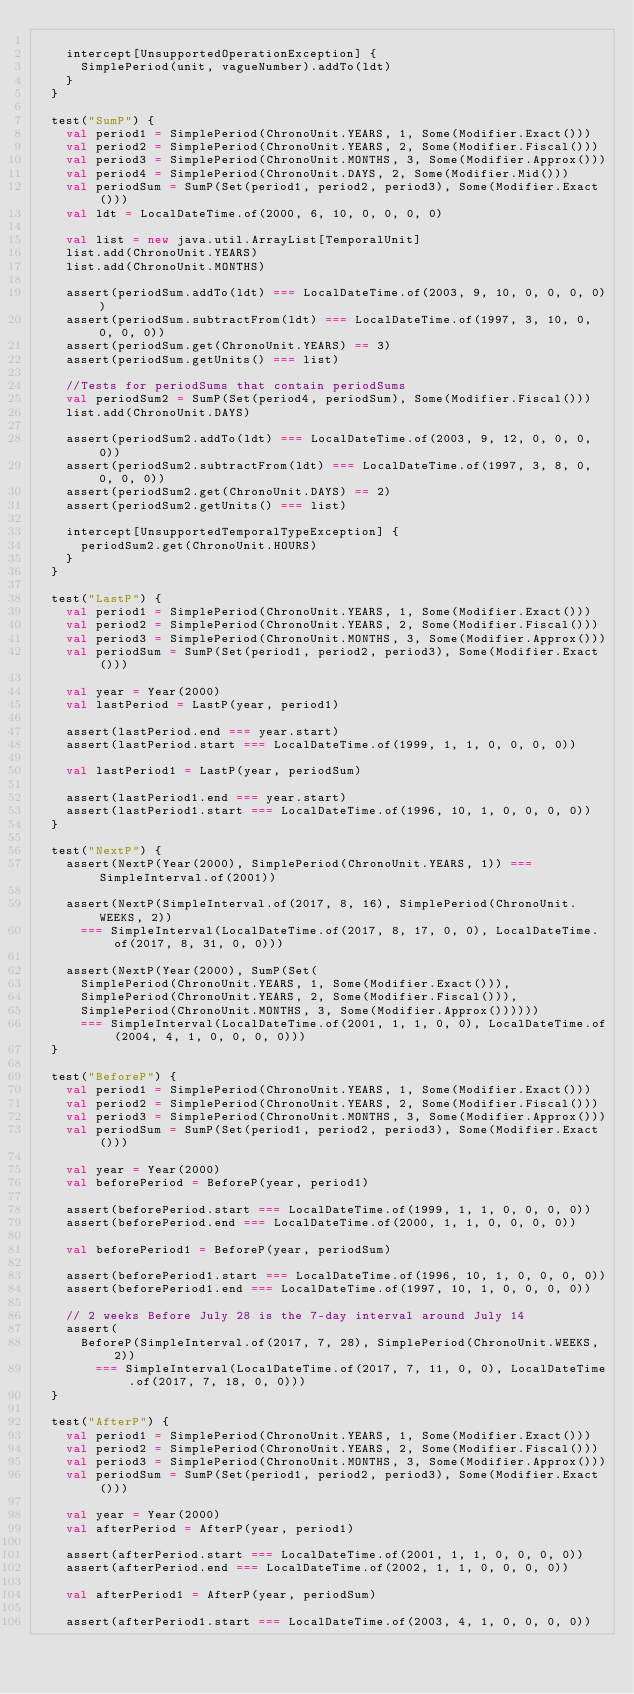Convert code to text. <code><loc_0><loc_0><loc_500><loc_500><_Scala_>
    intercept[UnsupportedOperationException] {
      SimplePeriod(unit, vagueNumber).addTo(ldt)
    }
  }

  test("SumP") {
    val period1 = SimplePeriod(ChronoUnit.YEARS, 1, Some(Modifier.Exact()))
    val period2 = SimplePeriod(ChronoUnit.YEARS, 2, Some(Modifier.Fiscal()))
    val period3 = SimplePeriod(ChronoUnit.MONTHS, 3, Some(Modifier.Approx()))
    val period4 = SimplePeriod(ChronoUnit.DAYS, 2, Some(Modifier.Mid()))
    val periodSum = SumP(Set(period1, period2, period3), Some(Modifier.Exact()))
    val ldt = LocalDateTime.of(2000, 6, 10, 0, 0, 0, 0)

    val list = new java.util.ArrayList[TemporalUnit]
    list.add(ChronoUnit.YEARS)
    list.add(ChronoUnit.MONTHS)

    assert(periodSum.addTo(ldt) === LocalDateTime.of(2003, 9, 10, 0, 0, 0, 0))
    assert(periodSum.subtractFrom(ldt) === LocalDateTime.of(1997, 3, 10, 0, 0, 0, 0))
    assert(periodSum.get(ChronoUnit.YEARS) == 3)
    assert(periodSum.getUnits() === list)

    //Tests for periodSums that contain periodSums
    val periodSum2 = SumP(Set(period4, periodSum), Some(Modifier.Fiscal()))
    list.add(ChronoUnit.DAYS)

    assert(periodSum2.addTo(ldt) === LocalDateTime.of(2003, 9, 12, 0, 0, 0, 0))
    assert(periodSum2.subtractFrom(ldt) === LocalDateTime.of(1997, 3, 8, 0, 0, 0, 0))
    assert(periodSum2.get(ChronoUnit.DAYS) == 2)
    assert(periodSum2.getUnits() === list)

    intercept[UnsupportedTemporalTypeException] {
      periodSum2.get(ChronoUnit.HOURS)
    }
  }

  test("LastP") {
    val period1 = SimplePeriod(ChronoUnit.YEARS, 1, Some(Modifier.Exact()))
    val period2 = SimplePeriod(ChronoUnit.YEARS, 2, Some(Modifier.Fiscal()))
    val period3 = SimplePeriod(ChronoUnit.MONTHS, 3, Some(Modifier.Approx()))
    val periodSum = SumP(Set(period1, period2, period3), Some(Modifier.Exact()))

    val year = Year(2000)
    val lastPeriod = LastP(year, period1)

    assert(lastPeriod.end === year.start)
    assert(lastPeriod.start === LocalDateTime.of(1999, 1, 1, 0, 0, 0, 0))

    val lastPeriod1 = LastP(year, periodSum)

    assert(lastPeriod1.end === year.start)
    assert(lastPeriod1.start === LocalDateTime.of(1996, 10, 1, 0, 0, 0, 0))
  }

  test("NextP") {
    assert(NextP(Year(2000), SimplePeriod(ChronoUnit.YEARS, 1)) === SimpleInterval.of(2001))

    assert(NextP(SimpleInterval.of(2017, 8, 16), SimplePeriod(ChronoUnit.WEEKS, 2))
      === SimpleInterval(LocalDateTime.of(2017, 8, 17, 0, 0), LocalDateTime.of(2017, 8, 31, 0, 0)))

    assert(NextP(Year(2000), SumP(Set(
      SimplePeriod(ChronoUnit.YEARS, 1, Some(Modifier.Exact())),
      SimplePeriod(ChronoUnit.YEARS, 2, Some(Modifier.Fiscal())),
      SimplePeriod(ChronoUnit.MONTHS, 3, Some(Modifier.Approx())))))
      === SimpleInterval(LocalDateTime.of(2001, 1, 1, 0, 0), LocalDateTime.of(2004, 4, 1, 0, 0, 0, 0)))
  }

  test("BeforeP") {
    val period1 = SimplePeriod(ChronoUnit.YEARS, 1, Some(Modifier.Exact()))
    val period2 = SimplePeriod(ChronoUnit.YEARS, 2, Some(Modifier.Fiscal()))
    val period3 = SimplePeriod(ChronoUnit.MONTHS, 3, Some(Modifier.Approx()))
    val periodSum = SumP(Set(period1, period2, period3), Some(Modifier.Exact()))

    val year = Year(2000)
    val beforePeriod = BeforeP(year, period1)

    assert(beforePeriod.start === LocalDateTime.of(1999, 1, 1, 0, 0, 0, 0))
    assert(beforePeriod.end === LocalDateTime.of(2000, 1, 1, 0, 0, 0, 0))

    val beforePeriod1 = BeforeP(year, periodSum)

    assert(beforePeriod1.start === LocalDateTime.of(1996, 10, 1, 0, 0, 0, 0))
    assert(beforePeriod1.end === LocalDateTime.of(1997, 10, 1, 0, 0, 0, 0))

    // 2 weeks Before July 28 is the 7-day interval around July 14
    assert(
      BeforeP(SimpleInterval.of(2017, 7, 28), SimplePeriod(ChronoUnit.WEEKS, 2))
        === SimpleInterval(LocalDateTime.of(2017, 7, 11, 0, 0), LocalDateTime.of(2017, 7, 18, 0, 0)))
  }

  test("AfterP") {
    val period1 = SimplePeriod(ChronoUnit.YEARS, 1, Some(Modifier.Exact()))
    val period2 = SimplePeriod(ChronoUnit.YEARS, 2, Some(Modifier.Fiscal()))
    val period3 = SimplePeriod(ChronoUnit.MONTHS, 3, Some(Modifier.Approx()))
    val periodSum = SumP(Set(period1, period2, period3), Some(Modifier.Exact()))

    val year = Year(2000)
    val afterPeriod = AfterP(year, period1)

    assert(afterPeriod.start === LocalDateTime.of(2001, 1, 1, 0, 0, 0, 0))
    assert(afterPeriod.end === LocalDateTime.of(2002, 1, 1, 0, 0, 0, 0))

    val afterPeriod1 = AfterP(year, periodSum)

    assert(afterPeriod1.start === LocalDateTime.of(2003, 4, 1, 0, 0, 0, 0))</code> 